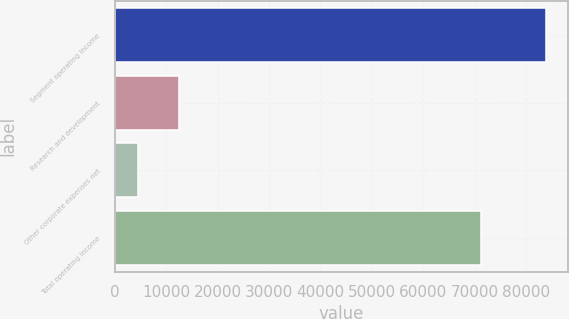Convert chart to OTSL. <chart><loc_0><loc_0><loc_500><loc_500><bar_chart><fcel>Segment operating income<fcel>Research and development<fcel>Other corporate expenses net<fcel>Total operating income<nl><fcel>83850<fcel>12482.7<fcel>4553<fcel>71230<nl></chart> 